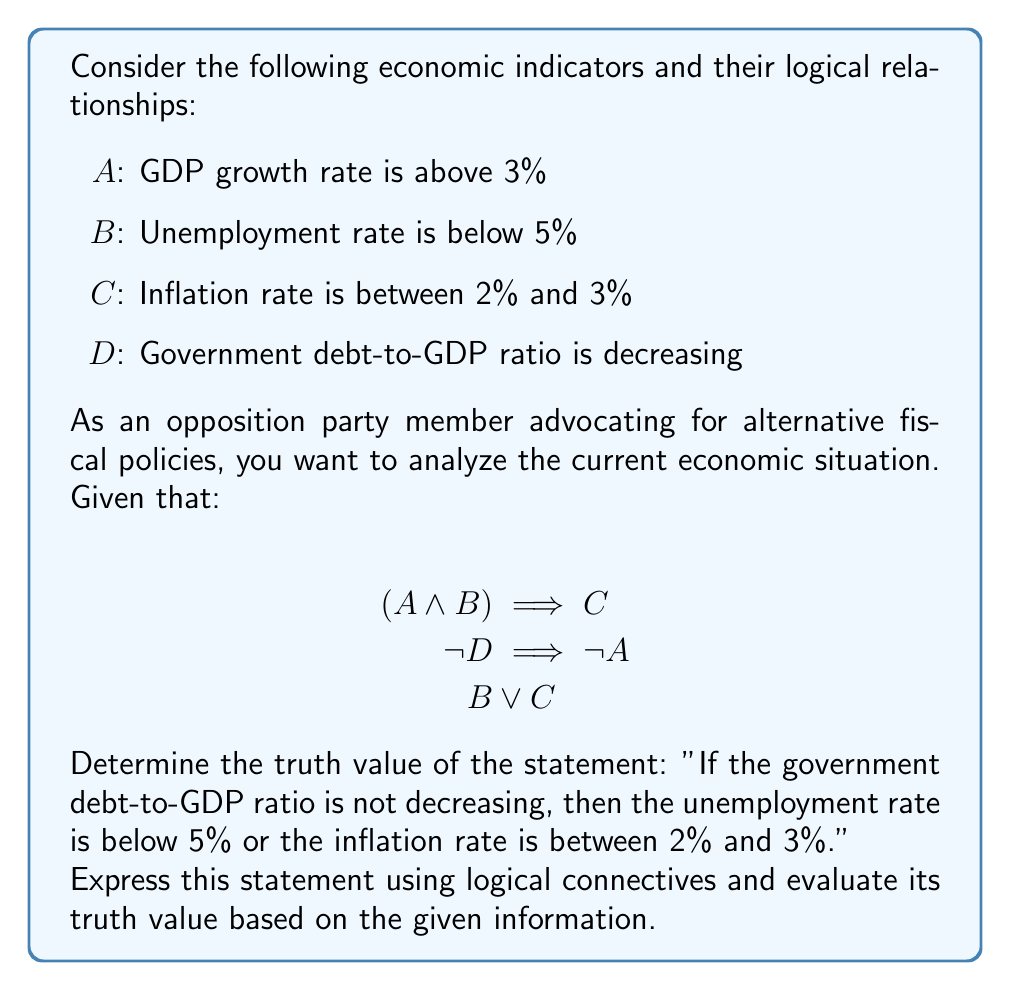Could you help me with this problem? Let's approach this step-by-step:

1) First, let's translate the given statement into logical connectives:
   "If the government debt-to-GDP ratio is not decreasing, then the unemployment rate is below 5% or the inflation rate is between 2% and 3%."
   This can be written as: $\neg D \implies (B \lor C)$

2) Now, let's analyze the given information:
   a) $(A \land B) \implies C$
   b) $\neg D \implies \neg A$
   c) $B \lor C$

3) From (b), we know that if D is false (debt-to-GDP ratio is not decreasing), then A is also false (GDP growth rate is not above 3%).

4) From (c), we know that either B is true or C is true, or both are true, regardless of other conditions.

5) The statement we're evaluating ($\neg D \implies (B \lor C)$) can be interpreted as:
   "If the debt-to-GDP ratio is not decreasing, then either the unemployment rate is below 5% or the inflation rate is between 2% and 3%."

6) Given that $B \lor C$ is always true (from step 4), the implication $\neg D \implies (B \lor C)$ will always be true, regardless of the truth value of D.

7) In logical terms, if the consequent of an implication is always true, the entire implication is always true, regardless of the antecedent.

Therefore, the given statement is always true based on the provided information.
Answer: True 